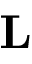<formula> <loc_0><loc_0><loc_500><loc_500>L</formula> 